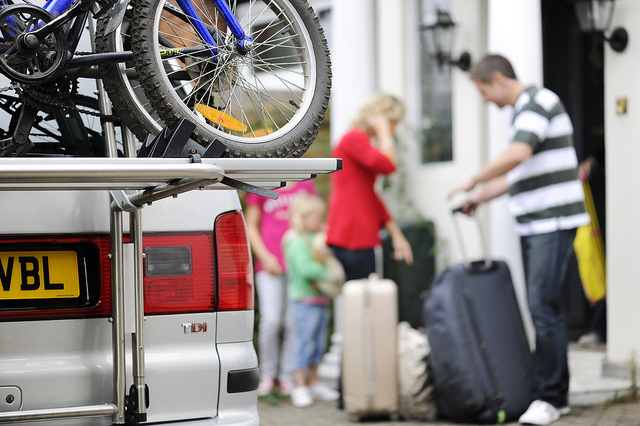Identify and read out the text in this image. VBL 